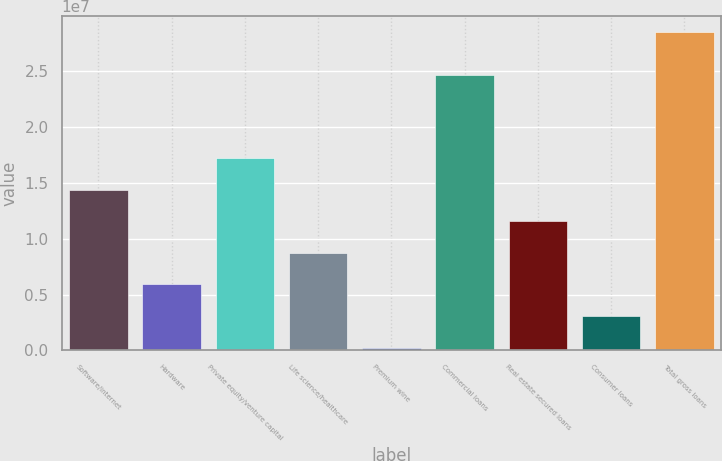<chart> <loc_0><loc_0><loc_500><loc_500><bar_chart><fcel>Software/internet<fcel>Hardware<fcel>Private equity/venture capital<fcel>Life science/healthcare<fcel>Premium wine<fcel>Commercial loans<fcel>Real estate secured loans<fcel>Consumer loans<fcel>Total gross loans<nl><fcel>1.43803e+07<fcel>5.90172e+06<fcel>1.72065e+07<fcel>8.72791e+06<fcel>249316<fcel>2.4631e+07<fcel>1.15541e+07<fcel>3.07552e+06<fcel>2.85113e+07<nl></chart> 